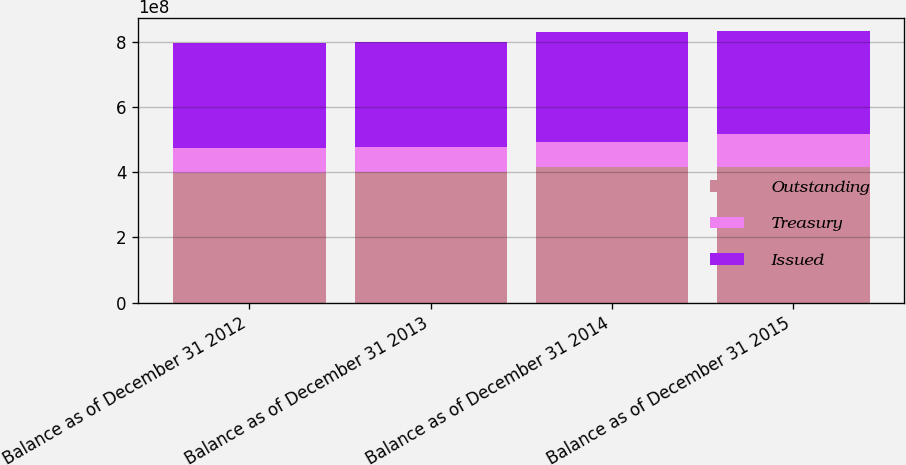<chart> <loc_0><loc_0><loc_500><loc_500><stacked_bar_chart><ecel><fcel>Balance as of December 31 2012<fcel>Balance as of December 31 2013<fcel>Balance as of December 31 2014<fcel>Balance as of December 31 2015<nl><fcel>Outstanding<fcel>3.99113e+08<fcel>4.01127e+08<fcel>4.15506e+08<fcel>4.1694e+08<nl><fcel>Treasury<fcel>7.65057e+07<fcel>7.73475e+07<fcel>7.88436e+07<fcel>1.0275e+08<nl><fcel>Issued<fcel>3.22607e+08<fcel>3.23779e+08<fcel>3.36663e+08<fcel>3.1419e+08<nl></chart> 